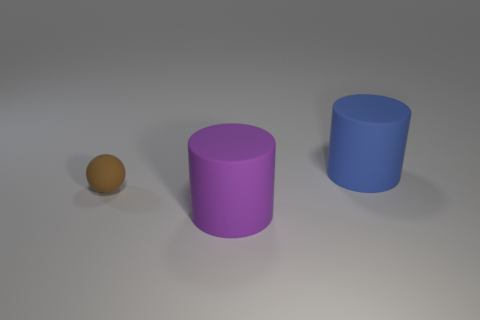Add 1 tiny red shiny things. How many objects exist? 4 Subtract all balls. How many objects are left? 2 Add 2 purple objects. How many purple objects exist? 3 Subtract 1 blue cylinders. How many objects are left? 2 Subtract all large blue matte cylinders. Subtract all purple rubber cylinders. How many objects are left? 1 Add 1 brown rubber balls. How many brown rubber balls are left? 2 